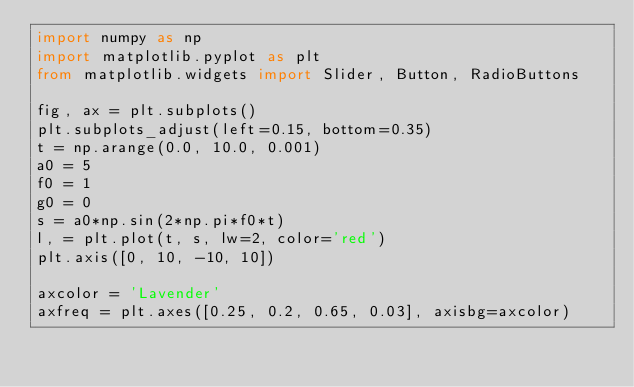Convert code to text. <code><loc_0><loc_0><loc_500><loc_500><_Python_>import numpy as np
import matplotlib.pyplot as plt
from matplotlib.widgets import Slider, Button, RadioButtons

fig, ax = plt.subplots()
plt.subplots_adjust(left=0.15, bottom=0.35)
t = np.arange(0.0, 10.0, 0.001)
a0 = 5
f0 = 1
g0 = 0
s = a0*np.sin(2*np.pi*f0*t)
l, = plt.plot(t, s, lw=2, color='red')
plt.axis([0, 10, -10, 10])

axcolor = 'Lavender'
axfreq = plt.axes([0.25, 0.2, 0.65, 0.03], axisbg=axcolor)</code> 